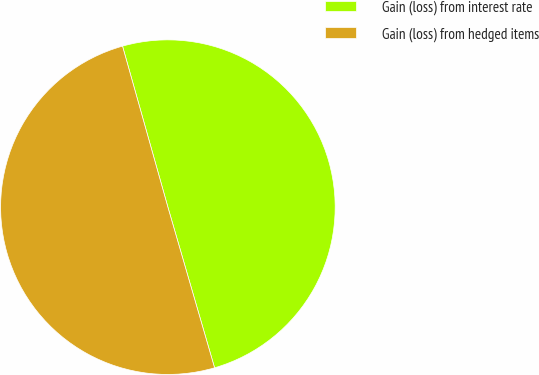<chart> <loc_0><loc_0><loc_500><loc_500><pie_chart><fcel>Gain (loss) from interest rate<fcel>Gain (loss) from hedged items<nl><fcel>49.87%<fcel>50.13%<nl></chart> 